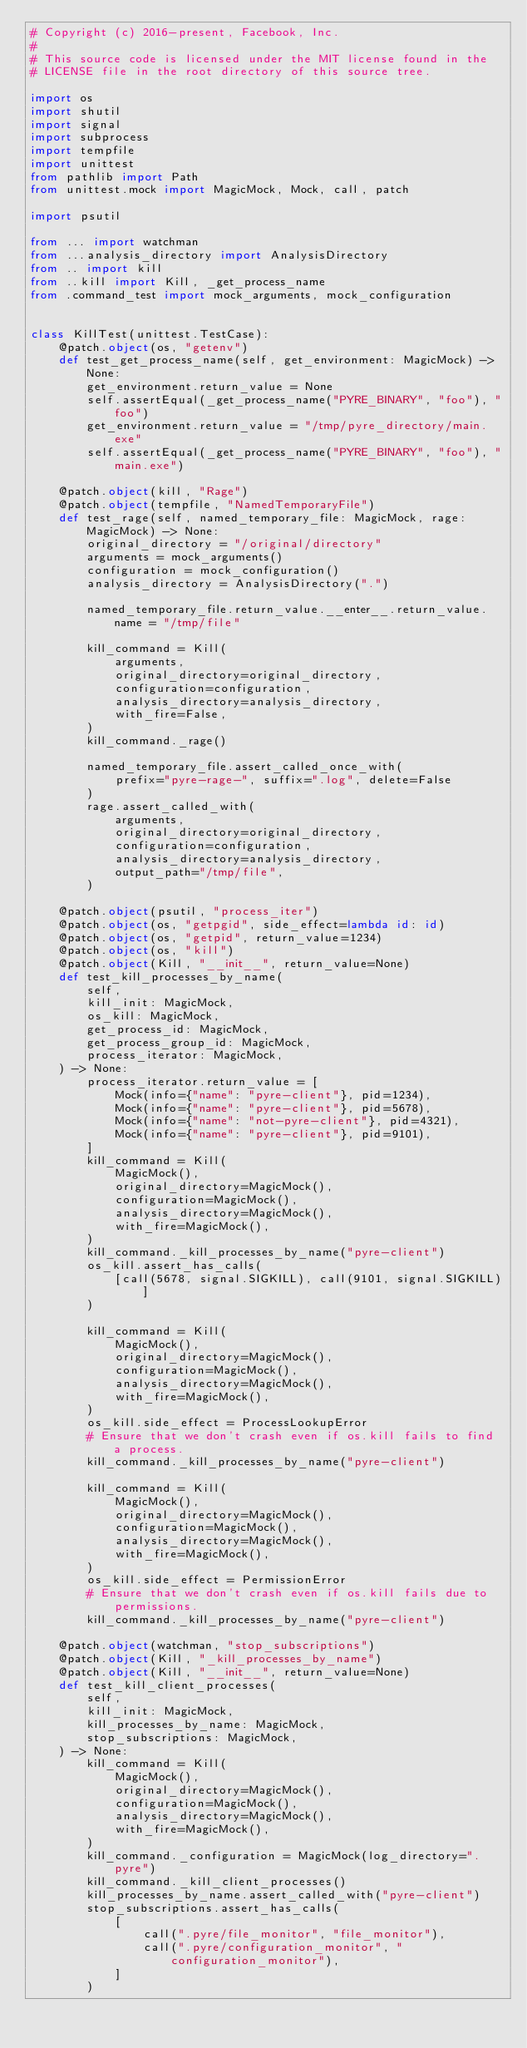Convert code to text. <code><loc_0><loc_0><loc_500><loc_500><_Python_># Copyright (c) 2016-present, Facebook, Inc.
#
# This source code is licensed under the MIT license found in the
# LICENSE file in the root directory of this source tree.

import os
import shutil
import signal
import subprocess
import tempfile
import unittest
from pathlib import Path
from unittest.mock import MagicMock, Mock, call, patch

import psutil

from ... import watchman
from ...analysis_directory import AnalysisDirectory
from .. import kill
from ..kill import Kill, _get_process_name
from .command_test import mock_arguments, mock_configuration


class KillTest(unittest.TestCase):
    @patch.object(os, "getenv")
    def test_get_process_name(self, get_environment: MagicMock) -> None:
        get_environment.return_value = None
        self.assertEqual(_get_process_name("PYRE_BINARY", "foo"), "foo")
        get_environment.return_value = "/tmp/pyre_directory/main.exe"
        self.assertEqual(_get_process_name("PYRE_BINARY", "foo"), "main.exe")

    @patch.object(kill, "Rage")
    @patch.object(tempfile, "NamedTemporaryFile")
    def test_rage(self, named_temporary_file: MagicMock, rage: MagicMock) -> None:
        original_directory = "/original/directory"
        arguments = mock_arguments()
        configuration = mock_configuration()
        analysis_directory = AnalysisDirectory(".")

        named_temporary_file.return_value.__enter__.return_value.name = "/tmp/file"

        kill_command = Kill(
            arguments,
            original_directory=original_directory,
            configuration=configuration,
            analysis_directory=analysis_directory,
            with_fire=False,
        )
        kill_command._rage()

        named_temporary_file.assert_called_once_with(
            prefix="pyre-rage-", suffix=".log", delete=False
        )
        rage.assert_called_with(
            arguments,
            original_directory=original_directory,
            configuration=configuration,
            analysis_directory=analysis_directory,
            output_path="/tmp/file",
        )

    @patch.object(psutil, "process_iter")
    @patch.object(os, "getpgid", side_effect=lambda id: id)
    @patch.object(os, "getpid", return_value=1234)
    @patch.object(os, "kill")
    @patch.object(Kill, "__init__", return_value=None)
    def test_kill_processes_by_name(
        self,
        kill_init: MagicMock,
        os_kill: MagicMock,
        get_process_id: MagicMock,
        get_process_group_id: MagicMock,
        process_iterator: MagicMock,
    ) -> None:
        process_iterator.return_value = [
            Mock(info={"name": "pyre-client"}, pid=1234),
            Mock(info={"name": "pyre-client"}, pid=5678),
            Mock(info={"name": "not-pyre-client"}, pid=4321),
            Mock(info={"name": "pyre-client"}, pid=9101),
        ]
        kill_command = Kill(
            MagicMock(),
            original_directory=MagicMock(),
            configuration=MagicMock(),
            analysis_directory=MagicMock(),
            with_fire=MagicMock(),
        )
        kill_command._kill_processes_by_name("pyre-client")
        os_kill.assert_has_calls(
            [call(5678, signal.SIGKILL), call(9101, signal.SIGKILL)]
        )

        kill_command = Kill(
            MagicMock(),
            original_directory=MagicMock(),
            configuration=MagicMock(),
            analysis_directory=MagicMock(),
            with_fire=MagicMock(),
        )
        os_kill.side_effect = ProcessLookupError
        # Ensure that we don't crash even if os.kill fails to find a process.
        kill_command._kill_processes_by_name("pyre-client")

        kill_command = Kill(
            MagicMock(),
            original_directory=MagicMock(),
            configuration=MagicMock(),
            analysis_directory=MagicMock(),
            with_fire=MagicMock(),
        )
        os_kill.side_effect = PermissionError
        # Ensure that we don't crash even if os.kill fails due to permissions.
        kill_command._kill_processes_by_name("pyre-client")

    @patch.object(watchman, "stop_subscriptions")
    @patch.object(Kill, "_kill_processes_by_name")
    @patch.object(Kill, "__init__", return_value=None)
    def test_kill_client_processes(
        self,
        kill_init: MagicMock,
        kill_processes_by_name: MagicMock,
        stop_subscriptions: MagicMock,
    ) -> None:
        kill_command = Kill(
            MagicMock(),
            original_directory=MagicMock(),
            configuration=MagicMock(),
            analysis_directory=MagicMock(),
            with_fire=MagicMock(),
        )
        kill_command._configuration = MagicMock(log_directory=".pyre")
        kill_command._kill_client_processes()
        kill_processes_by_name.assert_called_with("pyre-client")
        stop_subscriptions.assert_has_calls(
            [
                call(".pyre/file_monitor", "file_monitor"),
                call(".pyre/configuration_monitor", "configuration_monitor"),
            ]
        )
</code> 